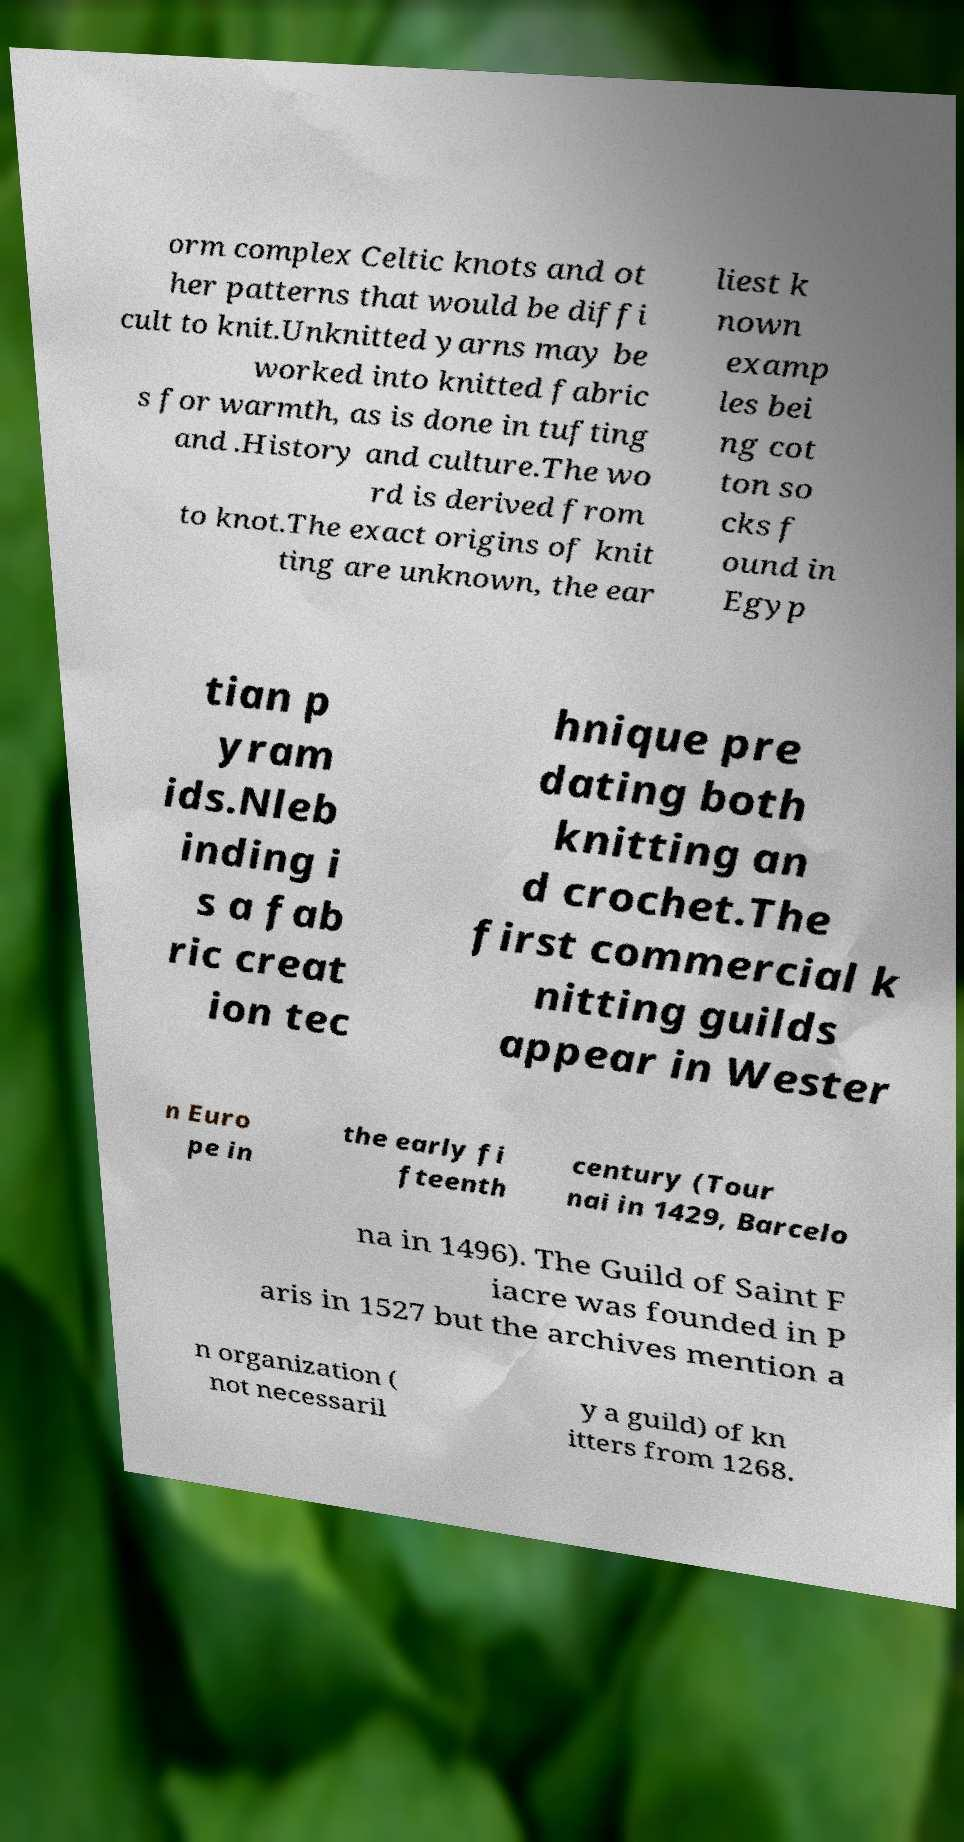There's text embedded in this image that I need extracted. Can you transcribe it verbatim? orm complex Celtic knots and ot her patterns that would be diffi cult to knit.Unknitted yarns may be worked into knitted fabric s for warmth, as is done in tufting and .History and culture.The wo rd is derived from to knot.The exact origins of knit ting are unknown, the ear liest k nown examp les bei ng cot ton so cks f ound in Egyp tian p yram ids.Nleb inding i s a fab ric creat ion tec hnique pre dating both knitting an d crochet.The first commercial k nitting guilds appear in Wester n Euro pe in the early fi fteenth century (Tour nai in 1429, Barcelo na in 1496). The Guild of Saint F iacre was founded in P aris in 1527 but the archives mention a n organization ( not necessaril y a guild) of kn itters from 1268. 